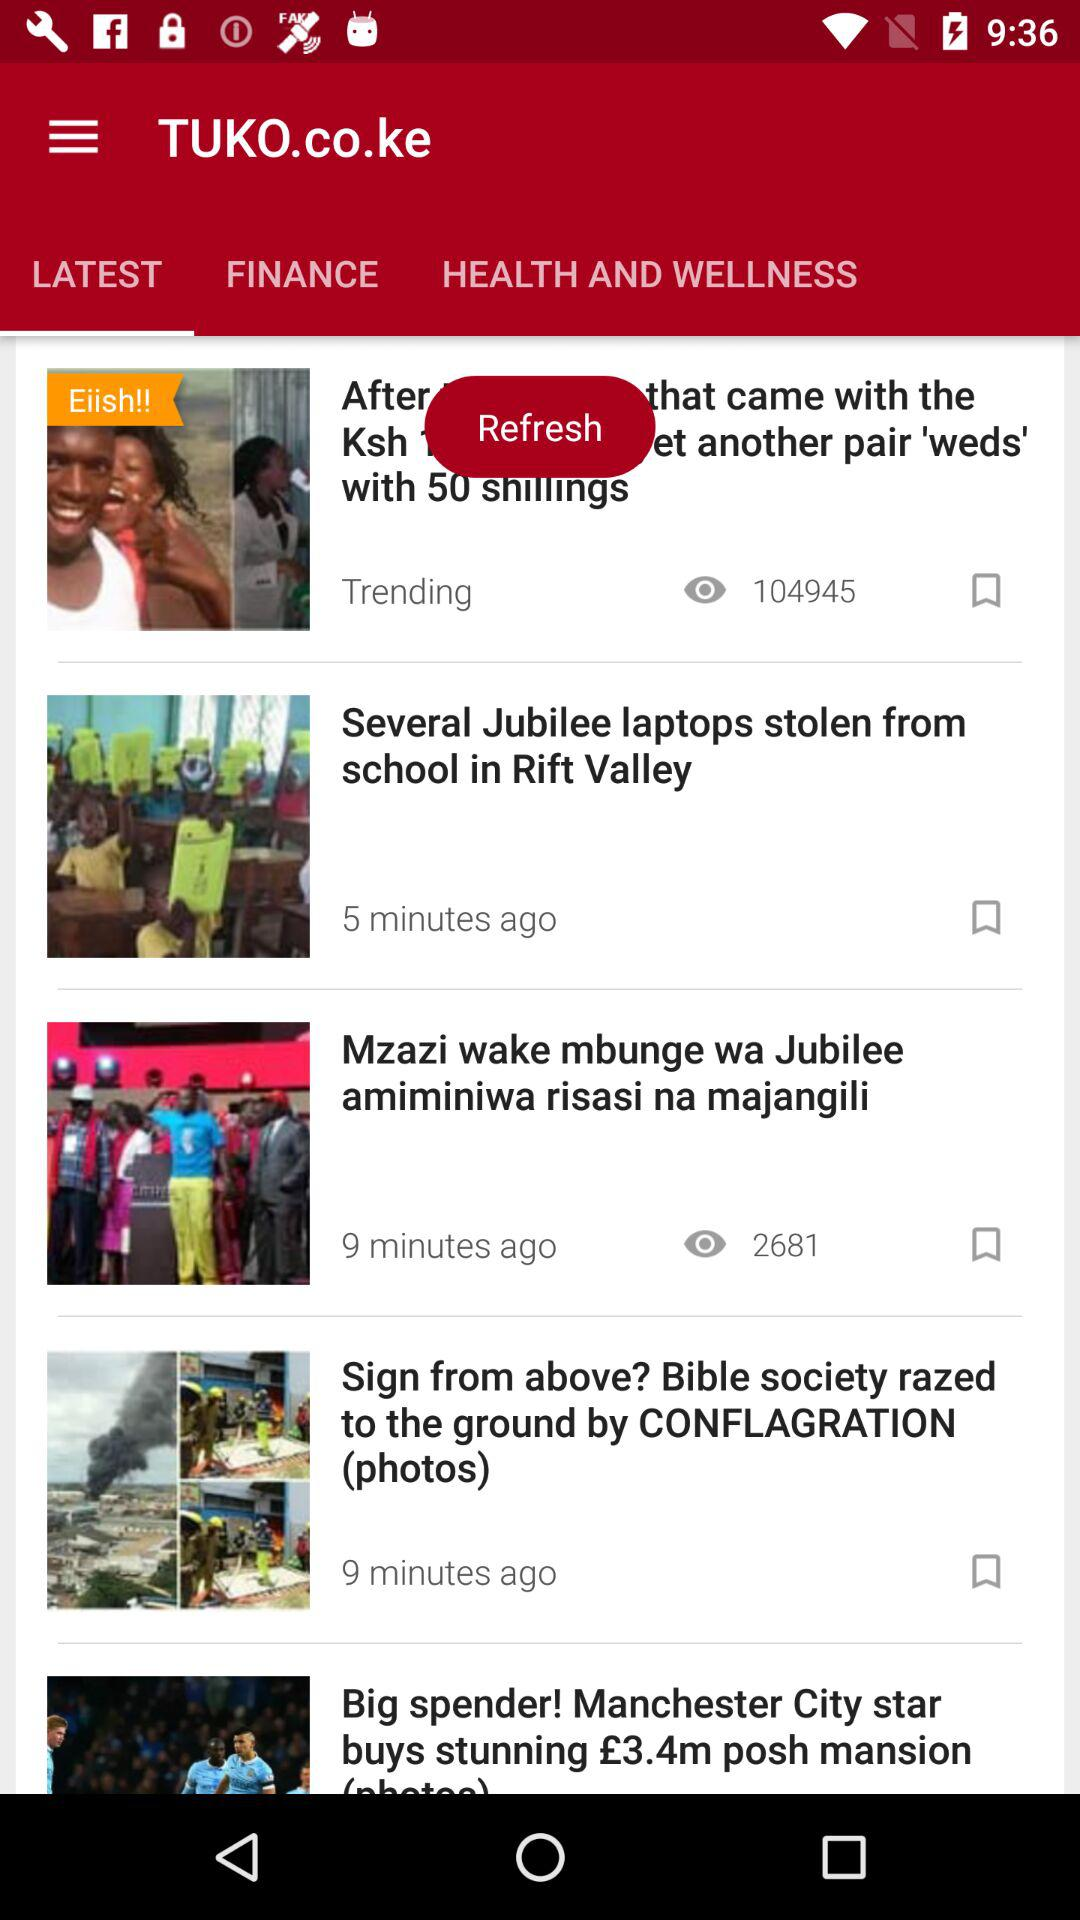Which tab is selected? The selected tab is "LATEST". 